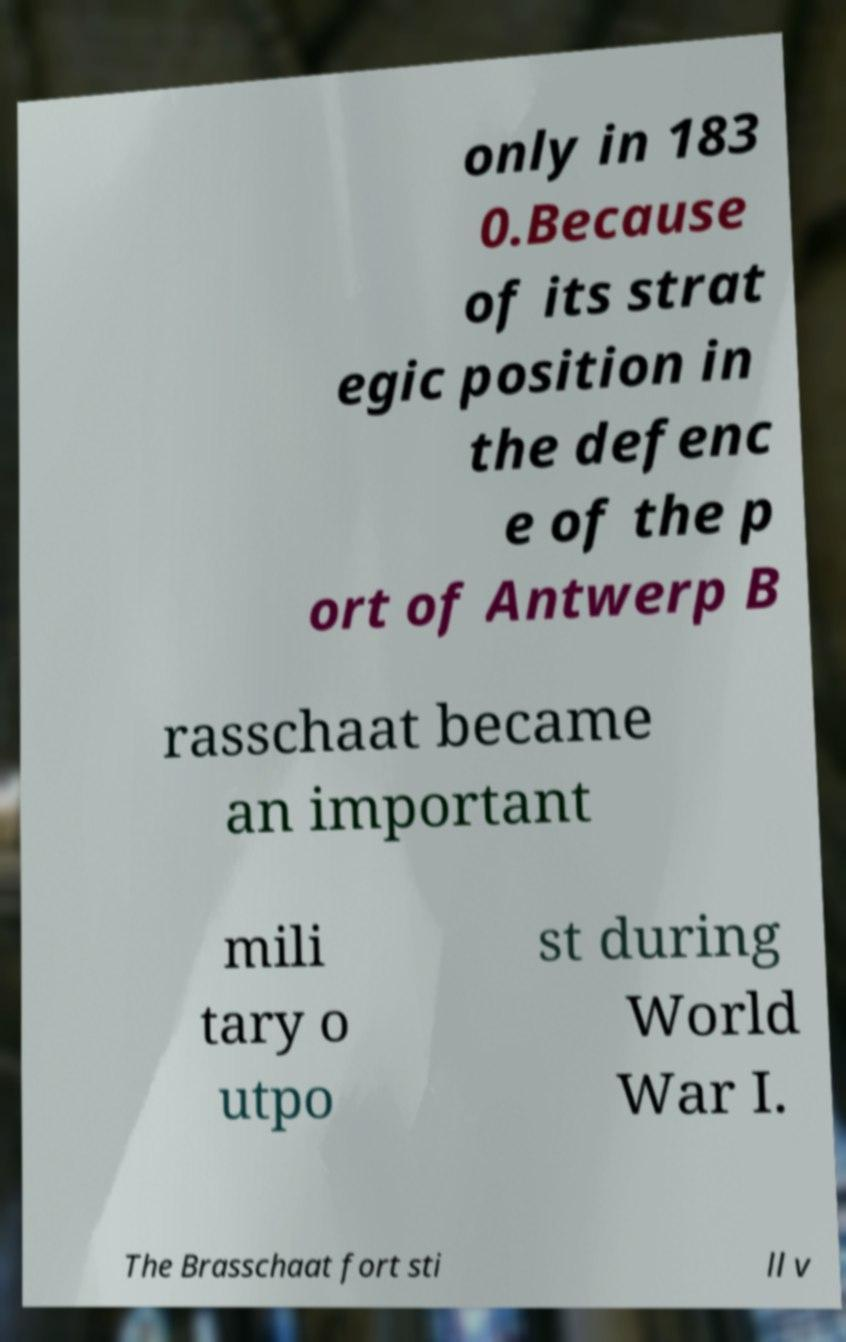Could you extract and type out the text from this image? only in 183 0.Because of its strat egic position in the defenc e of the p ort of Antwerp B rasschaat became an important mili tary o utpo st during World War I. The Brasschaat fort sti ll v 